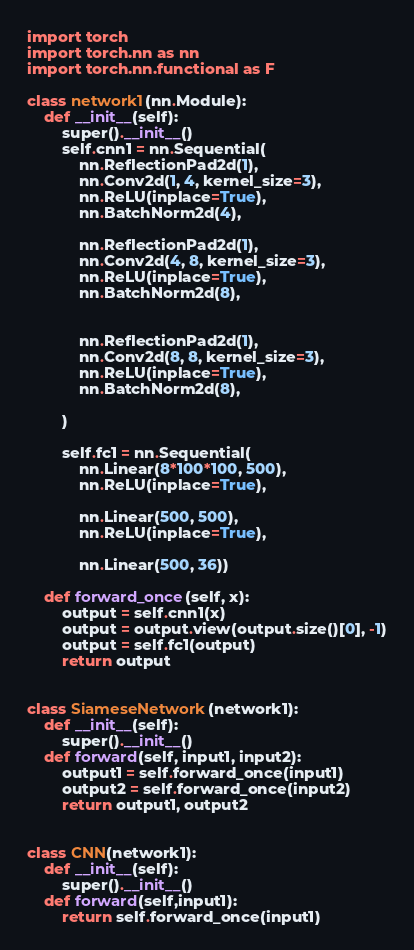<code> <loc_0><loc_0><loc_500><loc_500><_Python_>import torch
import torch.nn as nn
import torch.nn.functional as F

class network1(nn.Module):
    def __init__(self):
        super().__init__()
        self.cnn1 = nn.Sequential(
            nn.ReflectionPad2d(1),
            nn.Conv2d(1, 4, kernel_size=3),
            nn.ReLU(inplace=True),
            nn.BatchNorm2d(4),
            
            nn.ReflectionPad2d(1),
            nn.Conv2d(4, 8, kernel_size=3),
            nn.ReLU(inplace=True),
            nn.BatchNorm2d(8),


            nn.ReflectionPad2d(1),
            nn.Conv2d(8, 8, kernel_size=3),
            nn.ReLU(inplace=True),
            nn.BatchNorm2d(8),

        )

        self.fc1 = nn.Sequential(
            nn.Linear(8*100*100, 500),
            nn.ReLU(inplace=True),

            nn.Linear(500, 500),
            nn.ReLU(inplace=True),

            nn.Linear(500, 36))

    def forward_once(self, x):
        output = self.cnn1(x)
        output = output.view(output.size()[0], -1)
        output = self.fc1(output)
        return output


class SiameseNetwork(network1):
    def __init__(self):
        super().__init__()
    def forward(self, input1, input2):
        output1 = self.forward_once(input1)
        output2 = self.forward_once(input2)
        return output1, output2


class CNN(network1):
    def __init__(self):
        super().__init__()
    def forward(self,input1):
        return self.forward_once(input1)
</code> 